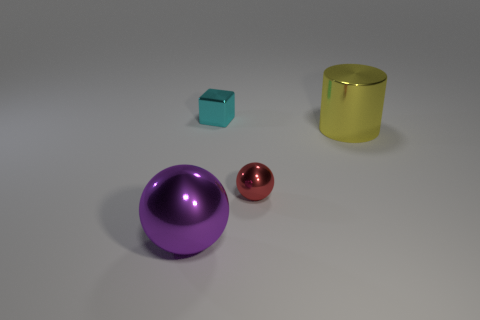What is the color of the small cube that is made of the same material as the purple sphere?
Ensure brevity in your answer.  Cyan. What number of cubes are either small red things or large yellow metallic things?
Your answer should be compact. 0. How many things are red matte spheres or objects that are to the right of the tiny red sphere?
Your answer should be very brief. 1. Are any tiny cubes visible?
Your answer should be compact. Yes. How many small metal balls are the same color as the large ball?
Your answer should be compact. 0. What size is the object that is behind the large thing right of the large purple metallic object?
Give a very brief answer. Small. Is there a tiny blue object made of the same material as the small red sphere?
Ensure brevity in your answer.  No. There is a object that is the same size as the shiny cylinder; what material is it?
Your answer should be compact. Metal. Do the big metallic object right of the big sphere and the shiny ball to the left of the small red thing have the same color?
Keep it short and to the point. No. Is there a tiny cyan metallic block that is to the right of the small shiny thing that is in front of the big yellow shiny thing?
Offer a terse response. No. 